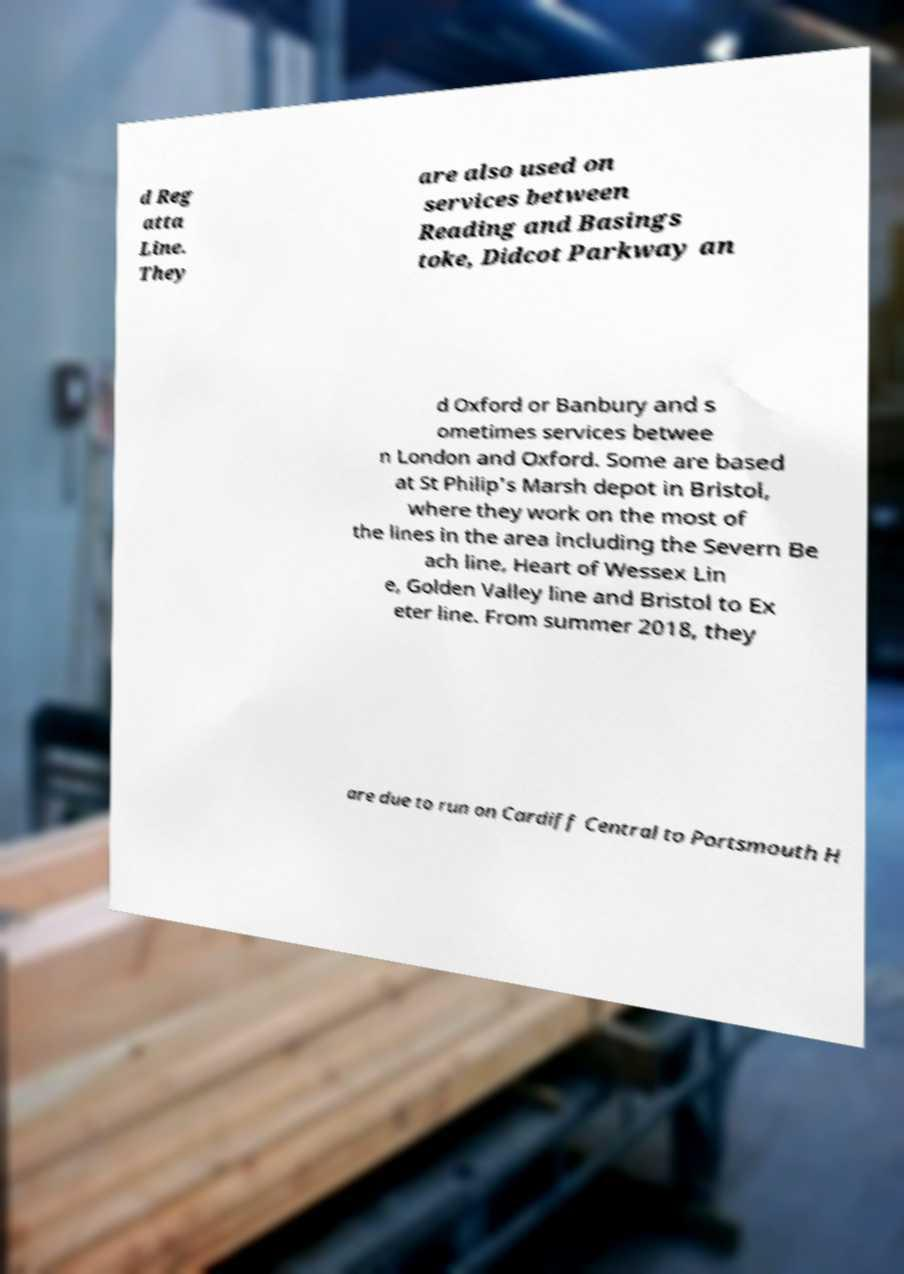What messages or text are displayed in this image? I need them in a readable, typed format. d Reg atta Line. They are also used on services between Reading and Basings toke, Didcot Parkway an d Oxford or Banbury and s ometimes services betwee n London and Oxford. Some are based at St Philip's Marsh depot in Bristol, where they work on the most of the lines in the area including the Severn Be ach line, Heart of Wessex Lin e, Golden Valley line and Bristol to Ex eter line. From summer 2018, they are due to run on Cardiff Central to Portsmouth H 